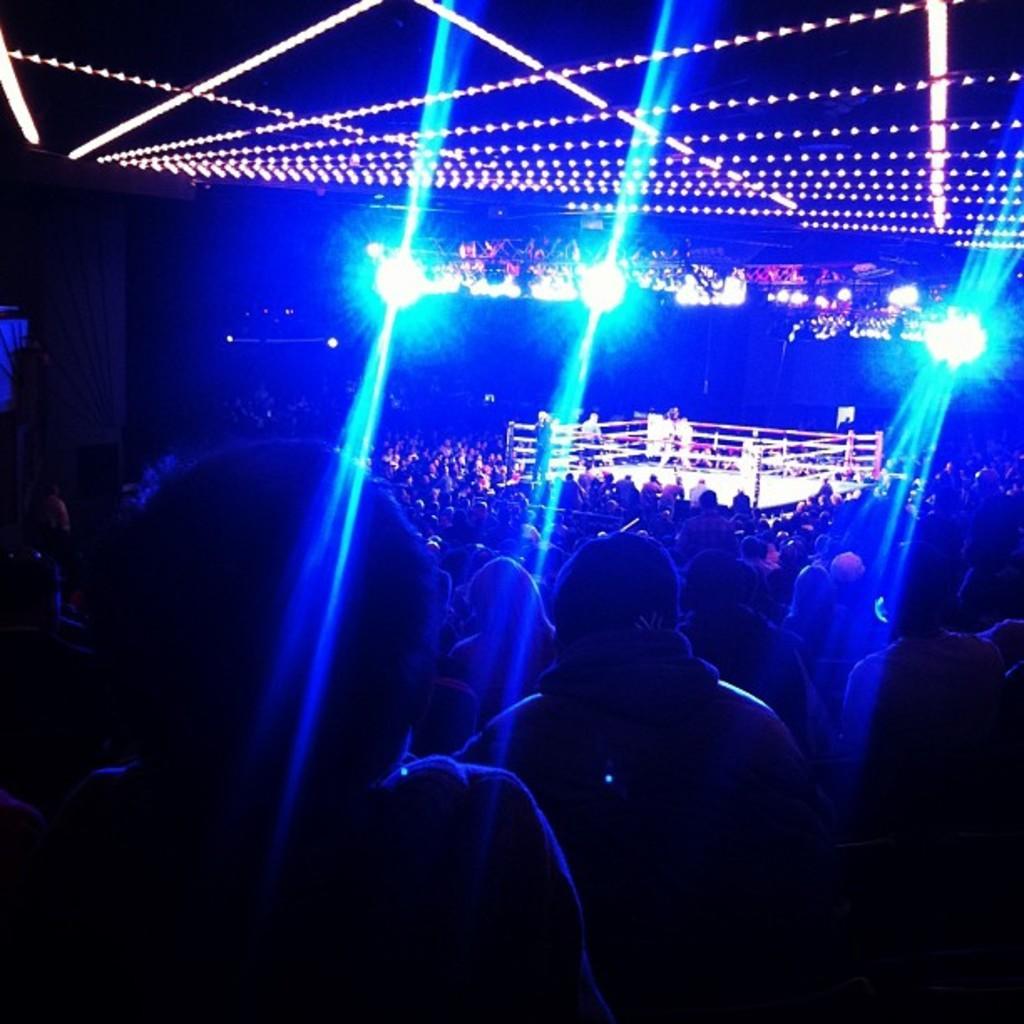Can you describe this image briefly? In the image we can see there are many people around and the corners of the image are dark. Here we can see lights and a battle ring, in the battle ring there are three people. 